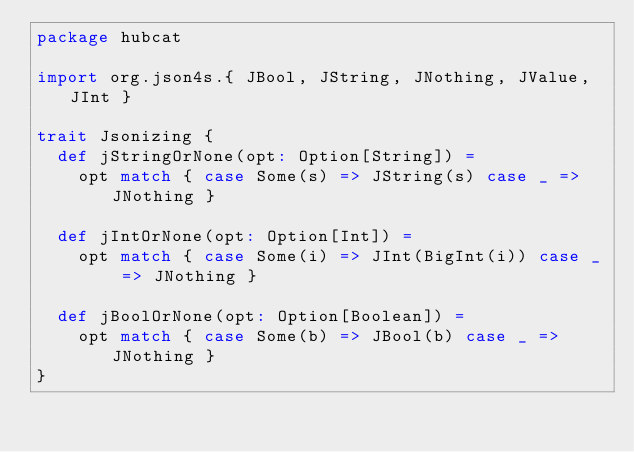<code> <loc_0><loc_0><loc_500><loc_500><_Scala_>package hubcat

import org.json4s.{ JBool, JString, JNothing, JValue, JInt }

trait Jsonizing {  
  def jStringOrNone(opt: Option[String]) =
    opt match { case Some(s) => JString(s) case _ => JNothing }

  def jIntOrNone(opt: Option[Int]) =
    opt match { case Some(i) => JInt(BigInt(i)) case _ => JNothing }

  def jBoolOrNone(opt: Option[Boolean]) =
    opt match { case Some(b) => JBool(b) case _ => JNothing }
}
</code> 